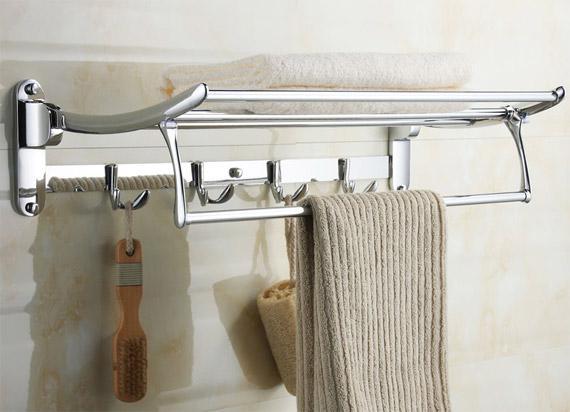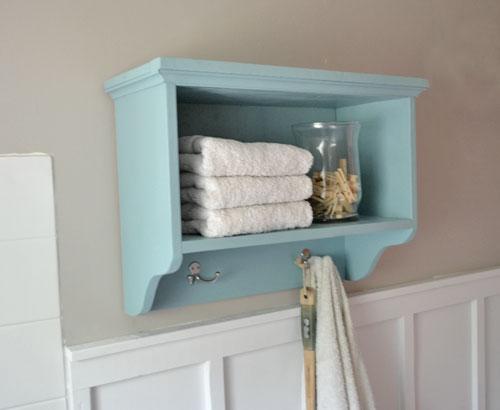The first image is the image on the left, the second image is the image on the right. Examine the images to the left and right. Is the description "All wooden bathroom shelves are stained dark and open on both ends, with no side enclosure boards." accurate? Answer yes or no. No. The first image is the image on the left, the second image is the image on the right. Considering the images on both sides, is "An image shows towels draped on hooks beneath a shelf containing a plant, jar of spools, and blue pump dispenser." valid? Answer yes or no. No. 